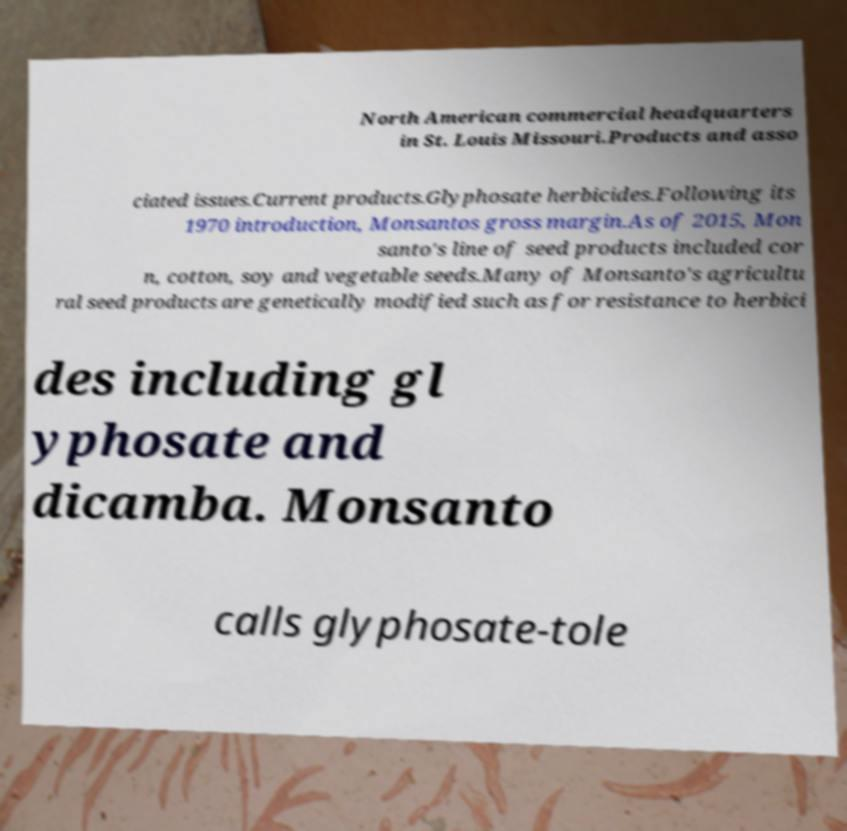Can you read and provide the text displayed in the image?This photo seems to have some interesting text. Can you extract and type it out for me? North American commercial headquarters in St. Louis Missouri.Products and asso ciated issues.Current products.Glyphosate herbicides.Following its 1970 introduction, Monsantos gross margin.As of 2015, Mon santo's line of seed products included cor n, cotton, soy and vegetable seeds.Many of Monsanto's agricultu ral seed products are genetically modified such as for resistance to herbici des including gl yphosate and dicamba. Monsanto calls glyphosate-tole 